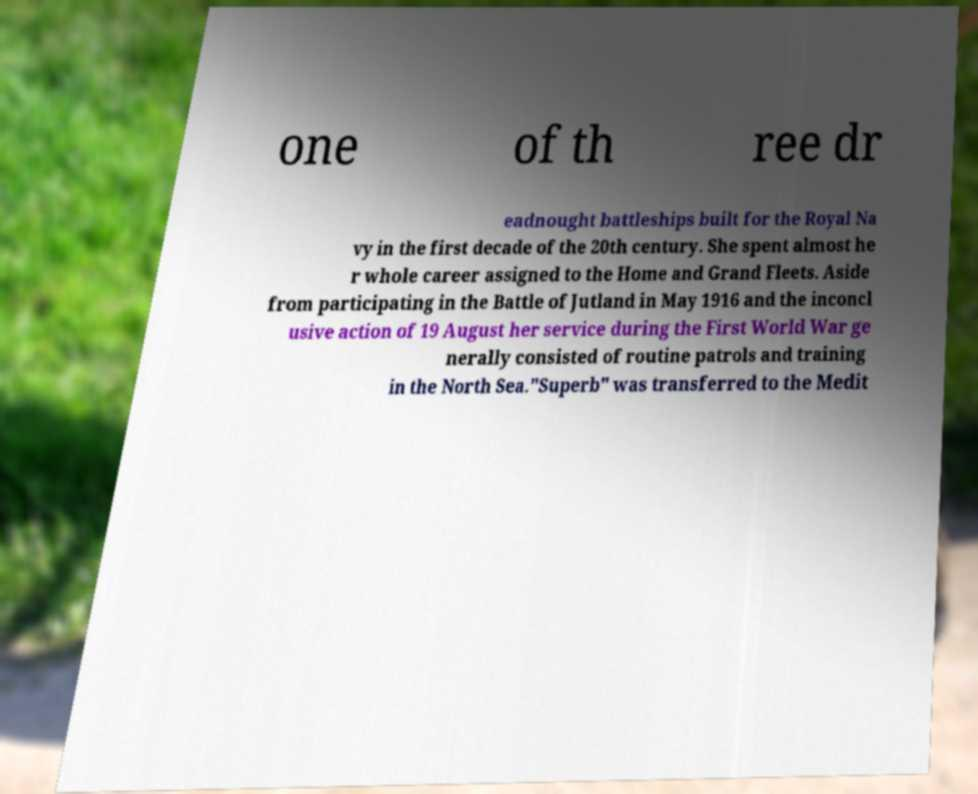Could you extract and type out the text from this image? one of th ree dr eadnought battleships built for the Royal Na vy in the first decade of the 20th century. She spent almost he r whole career assigned to the Home and Grand Fleets. Aside from participating in the Battle of Jutland in May 1916 and the inconcl usive action of 19 August her service during the First World War ge nerally consisted of routine patrols and training in the North Sea."Superb" was transferred to the Medit 